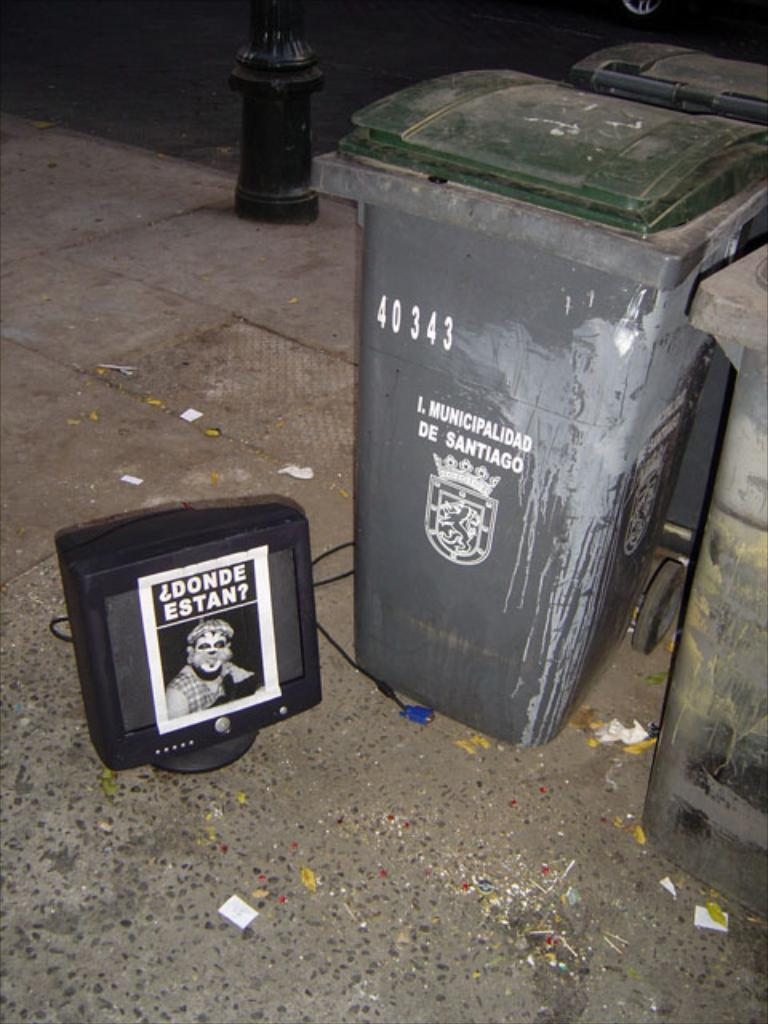<image>
Give a short and clear explanation of the subsequent image. A computer monitor says "donde estan?" and is sitting on the ground. 